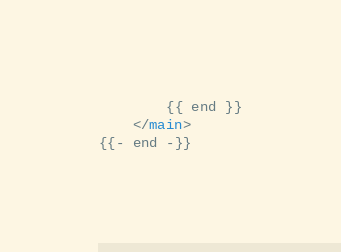<code> <loc_0><loc_0><loc_500><loc_500><_HTML_>        {{ end }}
    </main>
{{- end -}}</code> 